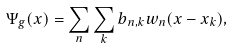<formula> <loc_0><loc_0><loc_500><loc_500>\Psi _ { g } ( x ) = \sum _ { n } \sum _ { k } b _ { n , k } w _ { n } ( x - x _ { k } ) ,</formula> 